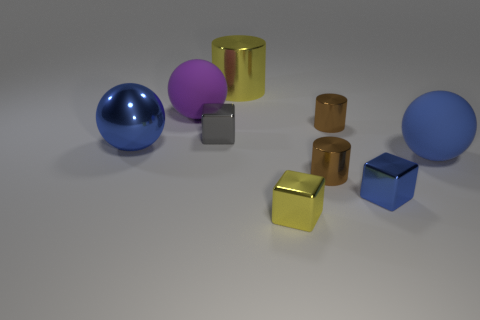Does the big sphere to the right of the big yellow metal cylinder have the same material as the block behind the large blue matte ball?
Your answer should be very brief. No. There is a matte object on the right side of the tiny metal cylinder behind the large ball that is right of the large yellow shiny cylinder; what size is it?
Your answer should be compact. Large. There is a blue sphere that is on the right side of the yellow metallic thing behind the gray metallic thing; are there any blue things that are left of it?
Offer a terse response. Yes. How many other things are there of the same color as the large cylinder?
Give a very brief answer. 1. There is a yellow metallic thing to the right of the large shiny cylinder; is it the same size as the blue metallic thing in front of the large blue matte ball?
Make the answer very short. Yes. Is the number of tiny brown objects that are in front of the purple matte ball the same as the number of cylinders that are behind the blue rubber ball?
Your answer should be very brief. Yes. Is there any other thing that is made of the same material as the big purple sphere?
Offer a very short reply. Yes. Do the blue cube and the yellow thing behind the large blue metallic object have the same size?
Make the answer very short. No. The cylinder that is behind the purple rubber thing that is in front of the large metal cylinder is made of what material?
Provide a succinct answer. Metal. Is the number of metallic things behind the purple rubber ball the same as the number of yellow objects?
Make the answer very short. No. 